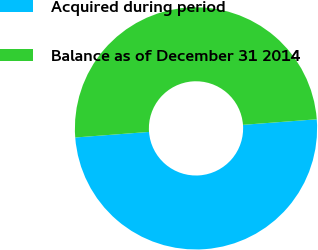Convert chart. <chart><loc_0><loc_0><loc_500><loc_500><pie_chart><fcel>Acquired during period<fcel>Balance as of December 31 2014<nl><fcel>50.0%<fcel>50.0%<nl></chart> 